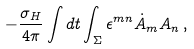<formula> <loc_0><loc_0><loc_500><loc_500>- \frac { \sigma _ { H } } { 4 \pi } \int d t \int _ { \Sigma } \epsilon ^ { m n } \dot { A } _ { m } A _ { n } \, ,</formula> 